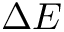<formula> <loc_0><loc_0><loc_500><loc_500>\Delta E</formula> 